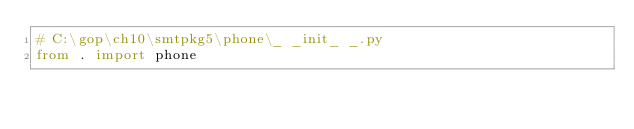Convert code to text. <code><loc_0><loc_0><loc_500><loc_500><_Python_># C:\gop\ch10\smtpkg5\phone\_ _init_ _.py
from . import phone
</code> 